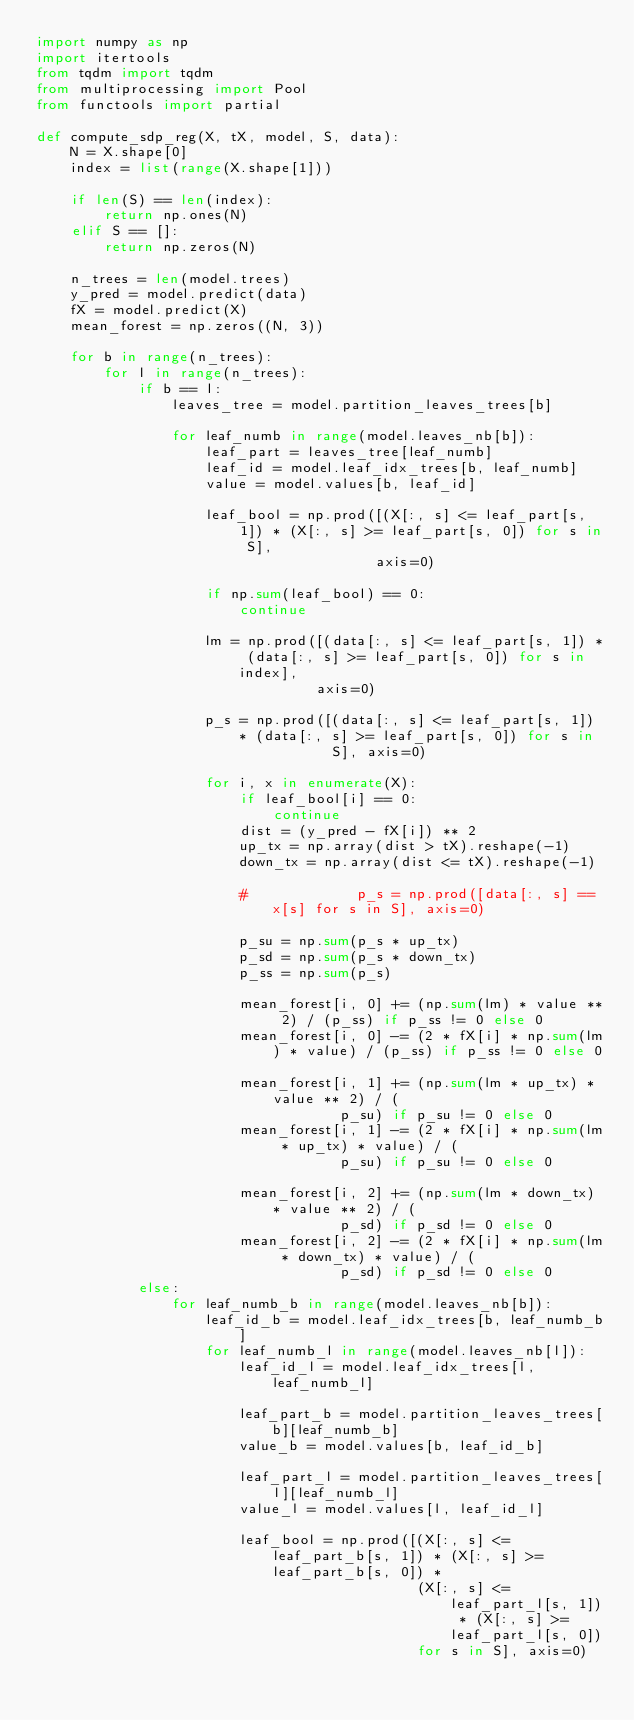Convert code to text. <code><loc_0><loc_0><loc_500><loc_500><_Python_>import numpy as np
import itertools
from tqdm import tqdm
from multiprocessing import Pool
from functools import partial

def compute_sdp_reg(X, tX, model, S, data):
    N = X.shape[0]
    index = list(range(X.shape[1]))

    if len(S) == len(index):
        return np.ones(N)
    elif S == []:
        return np.zeros(N)

    n_trees = len(model.trees)
    y_pred = model.predict(data)
    fX = model.predict(X)
    mean_forest = np.zeros((N, 3))

    for b in range(n_trees):
        for l in range(n_trees):
            if b == l:
                leaves_tree = model.partition_leaves_trees[b]

                for leaf_numb in range(model.leaves_nb[b]):
                    leaf_part = leaves_tree[leaf_numb]
                    leaf_id = model.leaf_idx_trees[b, leaf_numb]
                    value = model.values[b, leaf_id]

                    leaf_bool = np.prod([(X[:, s] <= leaf_part[s, 1]) * (X[:, s] >= leaf_part[s, 0]) for s in S],
                                        axis=0)

                    if np.sum(leaf_bool) == 0:
                        continue

                    lm = np.prod([(data[:, s] <= leaf_part[s, 1]) * (data[:, s] >= leaf_part[s, 0]) for s in index],
                                 axis=0)

                    p_s = np.prod([(data[:, s] <= leaf_part[s, 1]) * (data[:, s] >= leaf_part[s, 0]) for s in
                                   S], axis=0)

                    for i, x in enumerate(X):
                        if leaf_bool[i] == 0:
                            continue
                        dist = (y_pred - fX[i]) ** 2
                        up_tx = np.array(dist > tX).reshape(-1)
                        down_tx = np.array(dist <= tX).reshape(-1)

                        #             p_s = np.prod([data[:, s] == x[s] for s in S], axis=0)

                        p_su = np.sum(p_s * up_tx)
                        p_sd = np.sum(p_s * down_tx)
                        p_ss = np.sum(p_s)

                        mean_forest[i, 0] += (np.sum(lm) * value ** 2) / (p_ss) if p_ss != 0 else 0
                        mean_forest[i, 0] -= (2 * fX[i] * np.sum(lm) * value) / (p_ss) if p_ss != 0 else 0

                        mean_forest[i, 1] += (np.sum(lm * up_tx) * value ** 2) / (
                                    p_su) if p_su != 0 else 0
                        mean_forest[i, 1] -= (2 * fX[i] * np.sum(lm * up_tx) * value) / (
                                    p_su) if p_su != 0 else 0

                        mean_forest[i, 2] += (np.sum(lm * down_tx) * value ** 2) / (
                                    p_sd) if p_sd != 0 else 0
                        mean_forest[i, 2] -= (2 * fX[i] * np.sum(lm * down_tx) * value) / (
                                    p_sd) if p_sd != 0 else 0
            else:
                for leaf_numb_b in range(model.leaves_nb[b]):
                    leaf_id_b = model.leaf_idx_trees[b, leaf_numb_b]
                    for leaf_numb_l in range(model.leaves_nb[l]):
                        leaf_id_l = model.leaf_idx_trees[l, leaf_numb_l]

                        leaf_part_b = model.partition_leaves_trees[b][leaf_numb_b]
                        value_b = model.values[b, leaf_id_b]

                        leaf_part_l = model.partition_leaves_trees[l][leaf_numb_l]
                        value_l = model.values[l, leaf_id_l]

                        leaf_bool = np.prod([(X[:, s] <= leaf_part_b[s, 1]) * (X[:, s] >= leaf_part_b[s, 0]) *
                                             (X[:, s] <= leaf_part_l[s, 1]) * (X[:, s] >= leaf_part_l[s, 0])
                                             for s in S], axis=0)
</code> 